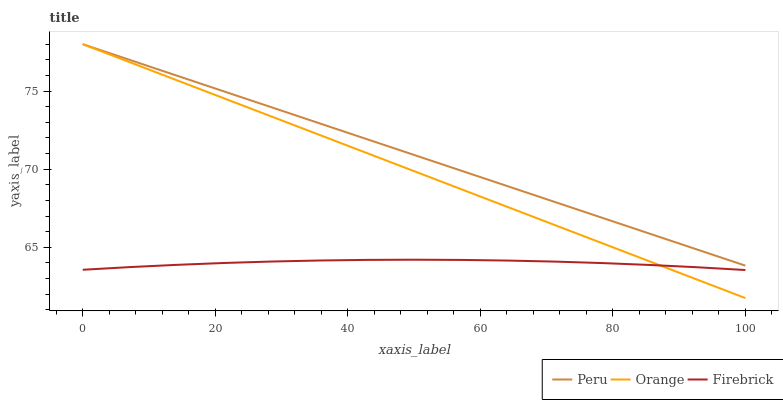Does Peru have the minimum area under the curve?
Answer yes or no. No. Does Firebrick have the maximum area under the curve?
Answer yes or no. No. Is Peru the smoothest?
Answer yes or no. No. Is Peru the roughest?
Answer yes or no. No. Does Firebrick have the lowest value?
Answer yes or no. No. Does Firebrick have the highest value?
Answer yes or no. No. Is Firebrick less than Peru?
Answer yes or no. Yes. Is Peru greater than Firebrick?
Answer yes or no. Yes. Does Firebrick intersect Peru?
Answer yes or no. No. 